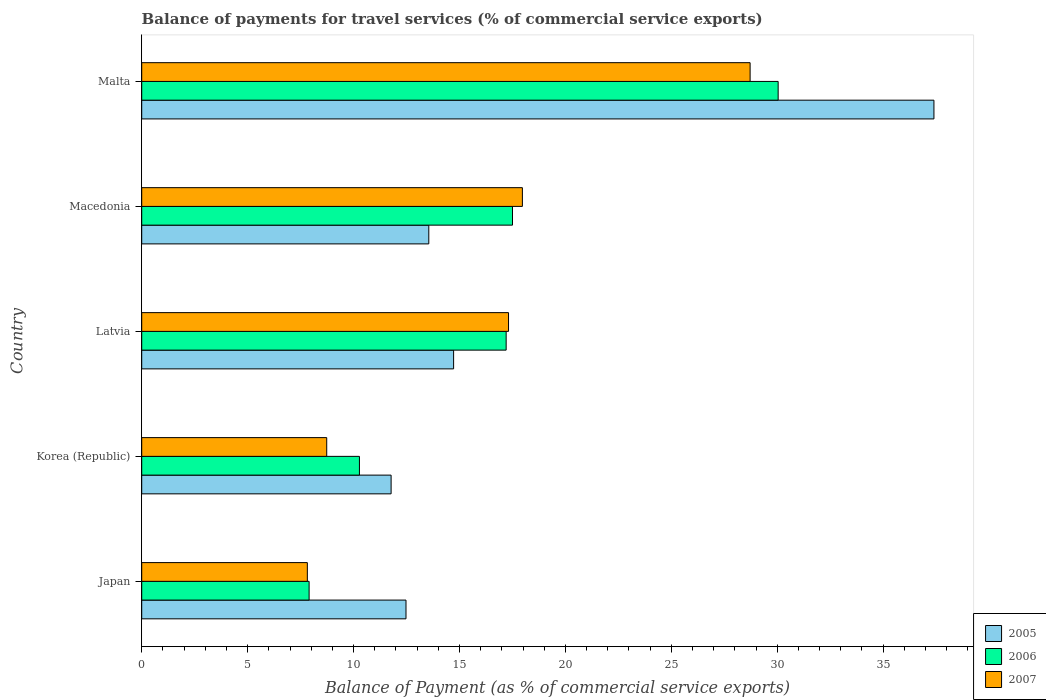Are the number of bars per tick equal to the number of legend labels?
Provide a succinct answer. Yes. Are the number of bars on each tick of the Y-axis equal?
Ensure brevity in your answer.  Yes. How many bars are there on the 4th tick from the top?
Provide a succinct answer. 3. What is the label of the 2nd group of bars from the top?
Offer a very short reply. Macedonia. In how many cases, is the number of bars for a given country not equal to the number of legend labels?
Your answer should be very brief. 0. What is the balance of payments for travel services in 2005 in Korea (Republic)?
Give a very brief answer. 11.77. Across all countries, what is the maximum balance of payments for travel services in 2006?
Your response must be concise. 30.05. Across all countries, what is the minimum balance of payments for travel services in 2006?
Provide a succinct answer. 7.9. In which country was the balance of payments for travel services in 2005 maximum?
Make the answer very short. Malta. What is the total balance of payments for travel services in 2007 in the graph?
Make the answer very short. 80.56. What is the difference between the balance of payments for travel services in 2006 in Korea (Republic) and that in Macedonia?
Ensure brevity in your answer.  -7.23. What is the difference between the balance of payments for travel services in 2005 in Macedonia and the balance of payments for travel services in 2007 in Latvia?
Your response must be concise. -3.76. What is the average balance of payments for travel services in 2006 per country?
Make the answer very short. 16.59. What is the difference between the balance of payments for travel services in 2006 and balance of payments for travel services in 2005 in Latvia?
Provide a succinct answer. 2.48. In how many countries, is the balance of payments for travel services in 2005 greater than 2 %?
Your answer should be very brief. 5. What is the ratio of the balance of payments for travel services in 2007 in Latvia to that in Malta?
Keep it short and to the point. 0.6. Is the balance of payments for travel services in 2007 in Macedonia less than that in Malta?
Provide a short and direct response. Yes. What is the difference between the highest and the second highest balance of payments for travel services in 2006?
Offer a very short reply. 12.54. What is the difference between the highest and the lowest balance of payments for travel services in 2006?
Offer a terse response. 22.14. Is it the case that in every country, the sum of the balance of payments for travel services in 2005 and balance of payments for travel services in 2007 is greater than the balance of payments for travel services in 2006?
Your response must be concise. Yes. How many bars are there?
Your answer should be very brief. 15. How many countries are there in the graph?
Give a very brief answer. 5. Does the graph contain any zero values?
Your answer should be very brief. No. Does the graph contain grids?
Make the answer very short. No. How many legend labels are there?
Ensure brevity in your answer.  3. How are the legend labels stacked?
Provide a succinct answer. Vertical. What is the title of the graph?
Keep it short and to the point. Balance of payments for travel services (% of commercial service exports). What is the label or title of the X-axis?
Make the answer very short. Balance of Payment (as % of commercial service exports). What is the Balance of Payment (as % of commercial service exports) in 2005 in Japan?
Offer a very short reply. 12.48. What is the Balance of Payment (as % of commercial service exports) in 2006 in Japan?
Provide a succinct answer. 7.9. What is the Balance of Payment (as % of commercial service exports) in 2007 in Japan?
Your answer should be very brief. 7.82. What is the Balance of Payment (as % of commercial service exports) in 2005 in Korea (Republic)?
Provide a short and direct response. 11.77. What is the Balance of Payment (as % of commercial service exports) in 2006 in Korea (Republic)?
Offer a terse response. 10.28. What is the Balance of Payment (as % of commercial service exports) of 2007 in Korea (Republic)?
Your answer should be very brief. 8.73. What is the Balance of Payment (as % of commercial service exports) in 2005 in Latvia?
Offer a very short reply. 14.72. What is the Balance of Payment (as % of commercial service exports) of 2006 in Latvia?
Your response must be concise. 17.2. What is the Balance of Payment (as % of commercial service exports) of 2007 in Latvia?
Provide a succinct answer. 17.32. What is the Balance of Payment (as % of commercial service exports) of 2005 in Macedonia?
Your answer should be compact. 13.55. What is the Balance of Payment (as % of commercial service exports) in 2006 in Macedonia?
Your answer should be very brief. 17.5. What is the Balance of Payment (as % of commercial service exports) of 2007 in Macedonia?
Your answer should be compact. 17.97. What is the Balance of Payment (as % of commercial service exports) in 2005 in Malta?
Your answer should be compact. 37.4. What is the Balance of Payment (as % of commercial service exports) of 2006 in Malta?
Offer a terse response. 30.05. What is the Balance of Payment (as % of commercial service exports) in 2007 in Malta?
Ensure brevity in your answer.  28.72. Across all countries, what is the maximum Balance of Payment (as % of commercial service exports) of 2005?
Provide a succinct answer. 37.4. Across all countries, what is the maximum Balance of Payment (as % of commercial service exports) of 2006?
Ensure brevity in your answer.  30.05. Across all countries, what is the maximum Balance of Payment (as % of commercial service exports) of 2007?
Provide a succinct answer. 28.72. Across all countries, what is the minimum Balance of Payment (as % of commercial service exports) in 2005?
Provide a short and direct response. 11.77. Across all countries, what is the minimum Balance of Payment (as % of commercial service exports) in 2006?
Keep it short and to the point. 7.9. Across all countries, what is the minimum Balance of Payment (as % of commercial service exports) of 2007?
Give a very brief answer. 7.82. What is the total Balance of Payment (as % of commercial service exports) of 2005 in the graph?
Provide a succinct answer. 89.93. What is the total Balance of Payment (as % of commercial service exports) of 2006 in the graph?
Your response must be concise. 82.94. What is the total Balance of Payment (as % of commercial service exports) of 2007 in the graph?
Keep it short and to the point. 80.56. What is the difference between the Balance of Payment (as % of commercial service exports) in 2005 in Japan and that in Korea (Republic)?
Ensure brevity in your answer.  0.7. What is the difference between the Balance of Payment (as % of commercial service exports) in 2006 in Japan and that in Korea (Republic)?
Your response must be concise. -2.38. What is the difference between the Balance of Payment (as % of commercial service exports) in 2007 in Japan and that in Korea (Republic)?
Your answer should be compact. -0.91. What is the difference between the Balance of Payment (as % of commercial service exports) in 2005 in Japan and that in Latvia?
Your response must be concise. -2.25. What is the difference between the Balance of Payment (as % of commercial service exports) in 2006 in Japan and that in Latvia?
Make the answer very short. -9.3. What is the difference between the Balance of Payment (as % of commercial service exports) of 2007 in Japan and that in Latvia?
Your answer should be compact. -9.5. What is the difference between the Balance of Payment (as % of commercial service exports) in 2005 in Japan and that in Macedonia?
Your answer should be very brief. -1.08. What is the difference between the Balance of Payment (as % of commercial service exports) of 2006 in Japan and that in Macedonia?
Your answer should be very brief. -9.6. What is the difference between the Balance of Payment (as % of commercial service exports) of 2007 in Japan and that in Macedonia?
Your answer should be very brief. -10.15. What is the difference between the Balance of Payment (as % of commercial service exports) in 2005 in Japan and that in Malta?
Make the answer very short. -24.92. What is the difference between the Balance of Payment (as % of commercial service exports) of 2006 in Japan and that in Malta?
Give a very brief answer. -22.14. What is the difference between the Balance of Payment (as % of commercial service exports) of 2007 in Japan and that in Malta?
Your answer should be very brief. -20.9. What is the difference between the Balance of Payment (as % of commercial service exports) in 2005 in Korea (Republic) and that in Latvia?
Your response must be concise. -2.95. What is the difference between the Balance of Payment (as % of commercial service exports) of 2006 in Korea (Republic) and that in Latvia?
Make the answer very short. -6.93. What is the difference between the Balance of Payment (as % of commercial service exports) in 2007 in Korea (Republic) and that in Latvia?
Make the answer very short. -8.58. What is the difference between the Balance of Payment (as % of commercial service exports) of 2005 in Korea (Republic) and that in Macedonia?
Offer a terse response. -1.78. What is the difference between the Balance of Payment (as % of commercial service exports) of 2006 in Korea (Republic) and that in Macedonia?
Ensure brevity in your answer.  -7.23. What is the difference between the Balance of Payment (as % of commercial service exports) of 2007 in Korea (Republic) and that in Macedonia?
Offer a terse response. -9.24. What is the difference between the Balance of Payment (as % of commercial service exports) in 2005 in Korea (Republic) and that in Malta?
Offer a very short reply. -25.63. What is the difference between the Balance of Payment (as % of commercial service exports) of 2006 in Korea (Republic) and that in Malta?
Your answer should be compact. -19.77. What is the difference between the Balance of Payment (as % of commercial service exports) in 2007 in Korea (Republic) and that in Malta?
Make the answer very short. -19.99. What is the difference between the Balance of Payment (as % of commercial service exports) of 2005 in Latvia and that in Macedonia?
Ensure brevity in your answer.  1.17. What is the difference between the Balance of Payment (as % of commercial service exports) of 2006 in Latvia and that in Macedonia?
Offer a terse response. -0.3. What is the difference between the Balance of Payment (as % of commercial service exports) in 2007 in Latvia and that in Macedonia?
Give a very brief answer. -0.65. What is the difference between the Balance of Payment (as % of commercial service exports) of 2005 in Latvia and that in Malta?
Your answer should be compact. -22.68. What is the difference between the Balance of Payment (as % of commercial service exports) of 2006 in Latvia and that in Malta?
Offer a terse response. -12.84. What is the difference between the Balance of Payment (as % of commercial service exports) in 2007 in Latvia and that in Malta?
Provide a short and direct response. -11.4. What is the difference between the Balance of Payment (as % of commercial service exports) in 2005 in Macedonia and that in Malta?
Offer a very short reply. -23.85. What is the difference between the Balance of Payment (as % of commercial service exports) in 2006 in Macedonia and that in Malta?
Offer a very short reply. -12.54. What is the difference between the Balance of Payment (as % of commercial service exports) of 2007 in Macedonia and that in Malta?
Your answer should be compact. -10.75. What is the difference between the Balance of Payment (as % of commercial service exports) of 2005 in Japan and the Balance of Payment (as % of commercial service exports) of 2006 in Korea (Republic)?
Offer a terse response. 2.2. What is the difference between the Balance of Payment (as % of commercial service exports) of 2005 in Japan and the Balance of Payment (as % of commercial service exports) of 2007 in Korea (Republic)?
Your answer should be very brief. 3.74. What is the difference between the Balance of Payment (as % of commercial service exports) of 2006 in Japan and the Balance of Payment (as % of commercial service exports) of 2007 in Korea (Republic)?
Your response must be concise. -0.83. What is the difference between the Balance of Payment (as % of commercial service exports) in 2005 in Japan and the Balance of Payment (as % of commercial service exports) in 2006 in Latvia?
Make the answer very short. -4.73. What is the difference between the Balance of Payment (as % of commercial service exports) of 2005 in Japan and the Balance of Payment (as % of commercial service exports) of 2007 in Latvia?
Provide a succinct answer. -4.84. What is the difference between the Balance of Payment (as % of commercial service exports) in 2006 in Japan and the Balance of Payment (as % of commercial service exports) in 2007 in Latvia?
Make the answer very short. -9.41. What is the difference between the Balance of Payment (as % of commercial service exports) of 2005 in Japan and the Balance of Payment (as % of commercial service exports) of 2006 in Macedonia?
Your response must be concise. -5.03. What is the difference between the Balance of Payment (as % of commercial service exports) of 2005 in Japan and the Balance of Payment (as % of commercial service exports) of 2007 in Macedonia?
Provide a short and direct response. -5.49. What is the difference between the Balance of Payment (as % of commercial service exports) of 2006 in Japan and the Balance of Payment (as % of commercial service exports) of 2007 in Macedonia?
Your response must be concise. -10.07. What is the difference between the Balance of Payment (as % of commercial service exports) in 2005 in Japan and the Balance of Payment (as % of commercial service exports) in 2006 in Malta?
Provide a succinct answer. -17.57. What is the difference between the Balance of Payment (as % of commercial service exports) in 2005 in Japan and the Balance of Payment (as % of commercial service exports) in 2007 in Malta?
Offer a terse response. -16.25. What is the difference between the Balance of Payment (as % of commercial service exports) in 2006 in Japan and the Balance of Payment (as % of commercial service exports) in 2007 in Malta?
Ensure brevity in your answer.  -20.82. What is the difference between the Balance of Payment (as % of commercial service exports) in 2005 in Korea (Republic) and the Balance of Payment (as % of commercial service exports) in 2006 in Latvia?
Your answer should be very brief. -5.43. What is the difference between the Balance of Payment (as % of commercial service exports) in 2005 in Korea (Republic) and the Balance of Payment (as % of commercial service exports) in 2007 in Latvia?
Provide a succinct answer. -5.54. What is the difference between the Balance of Payment (as % of commercial service exports) of 2006 in Korea (Republic) and the Balance of Payment (as % of commercial service exports) of 2007 in Latvia?
Offer a terse response. -7.04. What is the difference between the Balance of Payment (as % of commercial service exports) of 2005 in Korea (Republic) and the Balance of Payment (as % of commercial service exports) of 2006 in Macedonia?
Your answer should be very brief. -5.73. What is the difference between the Balance of Payment (as % of commercial service exports) of 2005 in Korea (Republic) and the Balance of Payment (as % of commercial service exports) of 2007 in Macedonia?
Offer a terse response. -6.2. What is the difference between the Balance of Payment (as % of commercial service exports) in 2006 in Korea (Republic) and the Balance of Payment (as % of commercial service exports) in 2007 in Macedonia?
Offer a terse response. -7.69. What is the difference between the Balance of Payment (as % of commercial service exports) in 2005 in Korea (Republic) and the Balance of Payment (as % of commercial service exports) in 2006 in Malta?
Provide a short and direct response. -18.27. What is the difference between the Balance of Payment (as % of commercial service exports) of 2005 in Korea (Republic) and the Balance of Payment (as % of commercial service exports) of 2007 in Malta?
Offer a terse response. -16.95. What is the difference between the Balance of Payment (as % of commercial service exports) in 2006 in Korea (Republic) and the Balance of Payment (as % of commercial service exports) in 2007 in Malta?
Offer a terse response. -18.44. What is the difference between the Balance of Payment (as % of commercial service exports) of 2005 in Latvia and the Balance of Payment (as % of commercial service exports) of 2006 in Macedonia?
Ensure brevity in your answer.  -2.78. What is the difference between the Balance of Payment (as % of commercial service exports) in 2005 in Latvia and the Balance of Payment (as % of commercial service exports) in 2007 in Macedonia?
Your answer should be very brief. -3.25. What is the difference between the Balance of Payment (as % of commercial service exports) of 2006 in Latvia and the Balance of Payment (as % of commercial service exports) of 2007 in Macedonia?
Your answer should be compact. -0.77. What is the difference between the Balance of Payment (as % of commercial service exports) of 2005 in Latvia and the Balance of Payment (as % of commercial service exports) of 2006 in Malta?
Your answer should be very brief. -15.32. What is the difference between the Balance of Payment (as % of commercial service exports) of 2005 in Latvia and the Balance of Payment (as % of commercial service exports) of 2007 in Malta?
Your response must be concise. -14. What is the difference between the Balance of Payment (as % of commercial service exports) in 2006 in Latvia and the Balance of Payment (as % of commercial service exports) in 2007 in Malta?
Make the answer very short. -11.52. What is the difference between the Balance of Payment (as % of commercial service exports) of 2005 in Macedonia and the Balance of Payment (as % of commercial service exports) of 2006 in Malta?
Your answer should be very brief. -16.49. What is the difference between the Balance of Payment (as % of commercial service exports) in 2005 in Macedonia and the Balance of Payment (as % of commercial service exports) in 2007 in Malta?
Your answer should be compact. -15.17. What is the difference between the Balance of Payment (as % of commercial service exports) of 2006 in Macedonia and the Balance of Payment (as % of commercial service exports) of 2007 in Malta?
Ensure brevity in your answer.  -11.22. What is the average Balance of Payment (as % of commercial service exports) in 2005 per country?
Offer a terse response. 17.99. What is the average Balance of Payment (as % of commercial service exports) of 2006 per country?
Offer a terse response. 16.59. What is the average Balance of Payment (as % of commercial service exports) of 2007 per country?
Provide a short and direct response. 16.11. What is the difference between the Balance of Payment (as % of commercial service exports) of 2005 and Balance of Payment (as % of commercial service exports) of 2006 in Japan?
Ensure brevity in your answer.  4.57. What is the difference between the Balance of Payment (as % of commercial service exports) of 2005 and Balance of Payment (as % of commercial service exports) of 2007 in Japan?
Give a very brief answer. 4.66. What is the difference between the Balance of Payment (as % of commercial service exports) of 2006 and Balance of Payment (as % of commercial service exports) of 2007 in Japan?
Offer a very short reply. 0.08. What is the difference between the Balance of Payment (as % of commercial service exports) in 2005 and Balance of Payment (as % of commercial service exports) in 2006 in Korea (Republic)?
Your answer should be compact. 1.49. What is the difference between the Balance of Payment (as % of commercial service exports) in 2005 and Balance of Payment (as % of commercial service exports) in 2007 in Korea (Republic)?
Provide a succinct answer. 3.04. What is the difference between the Balance of Payment (as % of commercial service exports) of 2006 and Balance of Payment (as % of commercial service exports) of 2007 in Korea (Republic)?
Your answer should be compact. 1.54. What is the difference between the Balance of Payment (as % of commercial service exports) in 2005 and Balance of Payment (as % of commercial service exports) in 2006 in Latvia?
Offer a very short reply. -2.48. What is the difference between the Balance of Payment (as % of commercial service exports) in 2005 and Balance of Payment (as % of commercial service exports) in 2007 in Latvia?
Provide a short and direct response. -2.59. What is the difference between the Balance of Payment (as % of commercial service exports) in 2006 and Balance of Payment (as % of commercial service exports) in 2007 in Latvia?
Provide a succinct answer. -0.11. What is the difference between the Balance of Payment (as % of commercial service exports) in 2005 and Balance of Payment (as % of commercial service exports) in 2006 in Macedonia?
Your response must be concise. -3.95. What is the difference between the Balance of Payment (as % of commercial service exports) in 2005 and Balance of Payment (as % of commercial service exports) in 2007 in Macedonia?
Provide a short and direct response. -4.42. What is the difference between the Balance of Payment (as % of commercial service exports) of 2006 and Balance of Payment (as % of commercial service exports) of 2007 in Macedonia?
Offer a very short reply. -0.47. What is the difference between the Balance of Payment (as % of commercial service exports) in 2005 and Balance of Payment (as % of commercial service exports) in 2006 in Malta?
Offer a very short reply. 7.35. What is the difference between the Balance of Payment (as % of commercial service exports) in 2005 and Balance of Payment (as % of commercial service exports) in 2007 in Malta?
Provide a short and direct response. 8.68. What is the difference between the Balance of Payment (as % of commercial service exports) of 2006 and Balance of Payment (as % of commercial service exports) of 2007 in Malta?
Ensure brevity in your answer.  1.32. What is the ratio of the Balance of Payment (as % of commercial service exports) in 2005 in Japan to that in Korea (Republic)?
Give a very brief answer. 1.06. What is the ratio of the Balance of Payment (as % of commercial service exports) in 2006 in Japan to that in Korea (Republic)?
Keep it short and to the point. 0.77. What is the ratio of the Balance of Payment (as % of commercial service exports) of 2007 in Japan to that in Korea (Republic)?
Ensure brevity in your answer.  0.9. What is the ratio of the Balance of Payment (as % of commercial service exports) in 2005 in Japan to that in Latvia?
Ensure brevity in your answer.  0.85. What is the ratio of the Balance of Payment (as % of commercial service exports) in 2006 in Japan to that in Latvia?
Make the answer very short. 0.46. What is the ratio of the Balance of Payment (as % of commercial service exports) of 2007 in Japan to that in Latvia?
Your answer should be compact. 0.45. What is the ratio of the Balance of Payment (as % of commercial service exports) in 2005 in Japan to that in Macedonia?
Your response must be concise. 0.92. What is the ratio of the Balance of Payment (as % of commercial service exports) in 2006 in Japan to that in Macedonia?
Your answer should be compact. 0.45. What is the ratio of the Balance of Payment (as % of commercial service exports) of 2007 in Japan to that in Macedonia?
Offer a very short reply. 0.44. What is the ratio of the Balance of Payment (as % of commercial service exports) in 2005 in Japan to that in Malta?
Give a very brief answer. 0.33. What is the ratio of the Balance of Payment (as % of commercial service exports) of 2006 in Japan to that in Malta?
Offer a terse response. 0.26. What is the ratio of the Balance of Payment (as % of commercial service exports) of 2007 in Japan to that in Malta?
Offer a terse response. 0.27. What is the ratio of the Balance of Payment (as % of commercial service exports) of 2005 in Korea (Republic) to that in Latvia?
Make the answer very short. 0.8. What is the ratio of the Balance of Payment (as % of commercial service exports) in 2006 in Korea (Republic) to that in Latvia?
Make the answer very short. 0.6. What is the ratio of the Balance of Payment (as % of commercial service exports) of 2007 in Korea (Republic) to that in Latvia?
Keep it short and to the point. 0.5. What is the ratio of the Balance of Payment (as % of commercial service exports) in 2005 in Korea (Republic) to that in Macedonia?
Give a very brief answer. 0.87. What is the ratio of the Balance of Payment (as % of commercial service exports) of 2006 in Korea (Republic) to that in Macedonia?
Your answer should be compact. 0.59. What is the ratio of the Balance of Payment (as % of commercial service exports) in 2007 in Korea (Republic) to that in Macedonia?
Provide a succinct answer. 0.49. What is the ratio of the Balance of Payment (as % of commercial service exports) in 2005 in Korea (Republic) to that in Malta?
Ensure brevity in your answer.  0.31. What is the ratio of the Balance of Payment (as % of commercial service exports) in 2006 in Korea (Republic) to that in Malta?
Offer a terse response. 0.34. What is the ratio of the Balance of Payment (as % of commercial service exports) of 2007 in Korea (Republic) to that in Malta?
Give a very brief answer. 0.3. What is the ratio of the Balance of Payment (as % of commercial service exports) in 2005 in Latvia to that in Macedonia?
Make the answer very short. 1.09. What is the ratio of the Balance of Payment (as % of commercial service exports) of 2006 in Latvia to that in Macedonia?
Keep it short and to the point. 0.98. What is the ratio of the Balance of Payment (as % of commercial service exports) in 2007 in Latvia to that in Macedonia?
Keep it short and to the point. 0.96. What is the ratio of the Balance of Payment (as % of commercial service exports) of 2005 in Latvia to that in Malta?
Make the answer very short. 0.39. What is the ratio of the Balance of Payment (as % of commercial service exports) in 2006 in Latvia to that in Malta?
Offer a very short reply. 0.57. What is the ratio of the Balance of Payment (as % of commercial service exports) in 2007 in Latvia to that in Malta?
Your response must be concise. 0.6. What is the ratio of the Balance of Payment (as % of commercial service exports) in 2005 in Macedonia to that in Malta?
Offer a terse response. 0.36. What is the ratio of the Balance of Payment (as % of commercial service exports) of 2006 in Macedonia to that in Malta?
Make the answer very short. 0.58. What is the ratio of the Balance of Payment (as % of commercial service exports) of 2007 in Macedonia to that in Malta?
Provide a succinct answer. 0.63. What is the difference between the highest and the second highest Balance of Payment (as % of commercial service exports) of 2005?
Make the answer very short. 22.68. What is the difference between the highest and the second highest Balance of Payment (as % of commercial service exports) of 2006?
Give a very brief answer. 12.54. What is the difference between the highest and the second highest Balance of Payment (as % of commercial service exports) in 2007?
Provide a short and direct response. 10.75. What is the difference between the highest and the lowest Balance of Payment (as % of commercial service exports) in 2005?
Keep it short and to the point. 25.63. What is the difference between the highest and the lowest Balance of Payment (as % of commercial service exports) in 2006?
Ensure brevity in your answer.  22.14. What is the difference between the highest and the lowest Balance of Payment (as % of commercial service exports) in 2007?
Provide a short and direct response. 20.9. 